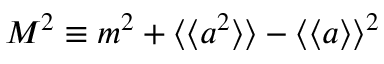<formula> <loc_0><loc_0><loc_500><loc_500>\begin{array} { r } { M ^ { 2 } \equiv m ^ { 2 } + \langle \langle a ^ { 2 } \rangle \rangle - \langle \langle a \rangle \rangle ^ { 2 } } \end{array}</formula> 